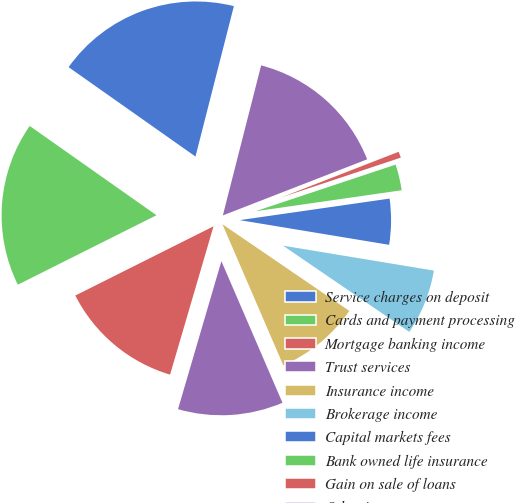Convert chart to OTSL. <chart><loc_0><loc_0><loc_500><loc_500><pie_chart><fcel>Service charges on deposit<fcel>Cards and payment processing<fcel>Mortgage banking income<fcel>Trust services<fcel>Insurance income<fcel>Brokerage income<fcel>Capital markets fees<fcel>Bank owned life insurance<fcel>Gain on sale of loans<fcel>Other income<nl><fcel>19.21%<fcel>17.16%<fcel>13.07%<fcel>11.02%<fcel>8.98%<fcel>6.93%<fcel>4.88%<fcel>2.84%<fcel>0.79%<fcel>15.12%<nl></chart> 